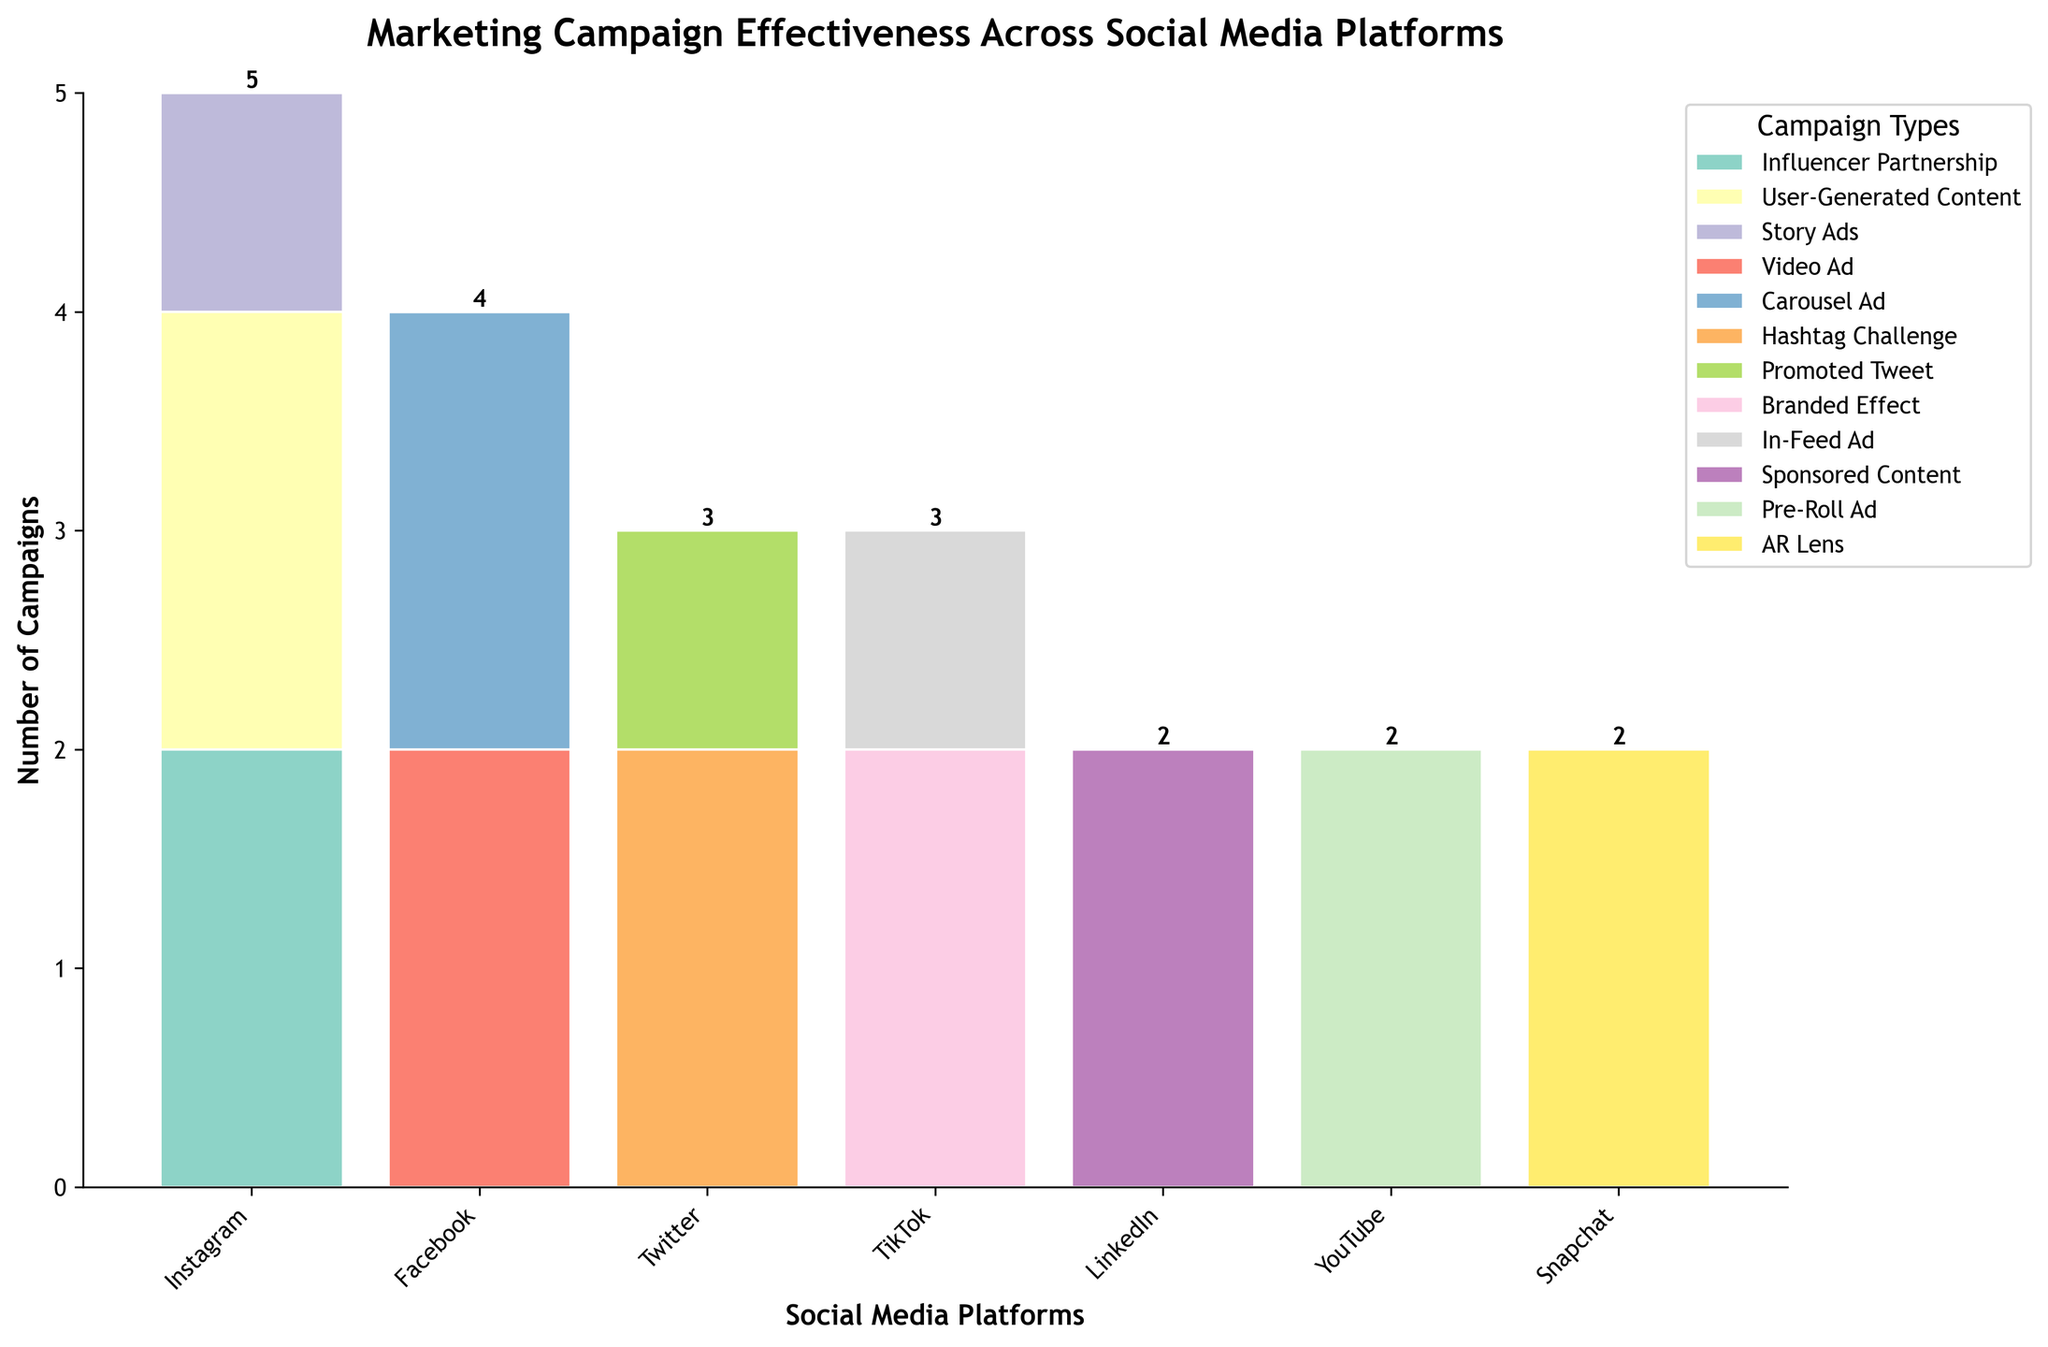what is the title of the plot? The title is displayed at the top of the plot in a larger, bold font, making it easily visible. The title of the plot is "Marketing Campaign Effectiveness Across Social Media Platforms".
Answer: Marketing Campaign Effectiveness Across Social Media Platforms which platform has the highest number of campaigns? By observing the heights of the bars for each platform, we can see that Instagram has the tallest total height of bars. Therefore, Instagram has the highest number of campaigns.
Answer: Instagram what is the total number of campaigns on Facebook? Adding up the values for all campaign types on Facebook, we see there are 3 campaigns for "Video Ad" and 2 for "Carousel Ad," making a total of 5 campaigns.
Answer: 5 how many types of campaigns are there on Snapchat? Looking at the legend and the bars for Snapchat, we see only one color, corresponding to "AR Lens" campaign type. Therefore, Snapchat has only one type of campaign.
Answer: 1 which campaign type is most common on Instagram? By examining the colors and the bar segments for Instagram, "Influencer Partnership" and "User-Generated Content" share the highest sections. However, the "Influencer Partnership" shows up prominently across different age groups.
Answer: Influencer Partnership between Instagram and TikTok, which one has a higher number of high engagement campaigns? By comparing the height of the "High" engagement segments (bars) on both platforms, we see Instagram has higher "High" engagement levels due to multiple campaigns contributing.
Answer: Instagram what percentage of campaigns on Twitter are Hashtag Challenges? Twitter has two campaign types: Hashtag Challenge and Promoted Tweet. There are 2 Hashtag Challenge campaigns out of 3 total, making the percentage (2/3)*100 = approximately 66.7%.
Answer: 66.7% how many platforms have only one type of campaign? By looking at the number of different colored segments for each platform, LinkedIn and Snapchat have only one type of campaign each. Therefore, there are 2 platforms with only one type of campaign.
Answer: 2 which platform-target engagement pair is unique in the "Low" engagement level? Observing the "Low" engagement level, only Story Ads on Instagram show this level, so the unique pair is Instagram with Story Ads targeting ages 35-44.
Answer: Instagram, Story Ads what is the most frequent campaign type across all platforms? By checking the cumulative heights of the different colored segments across all platforms, "User-Generated Content" on Instagram and repeated campaign types indicate "Influencer Partnership" appears more frequently.
Answer: Influencer Partnership 